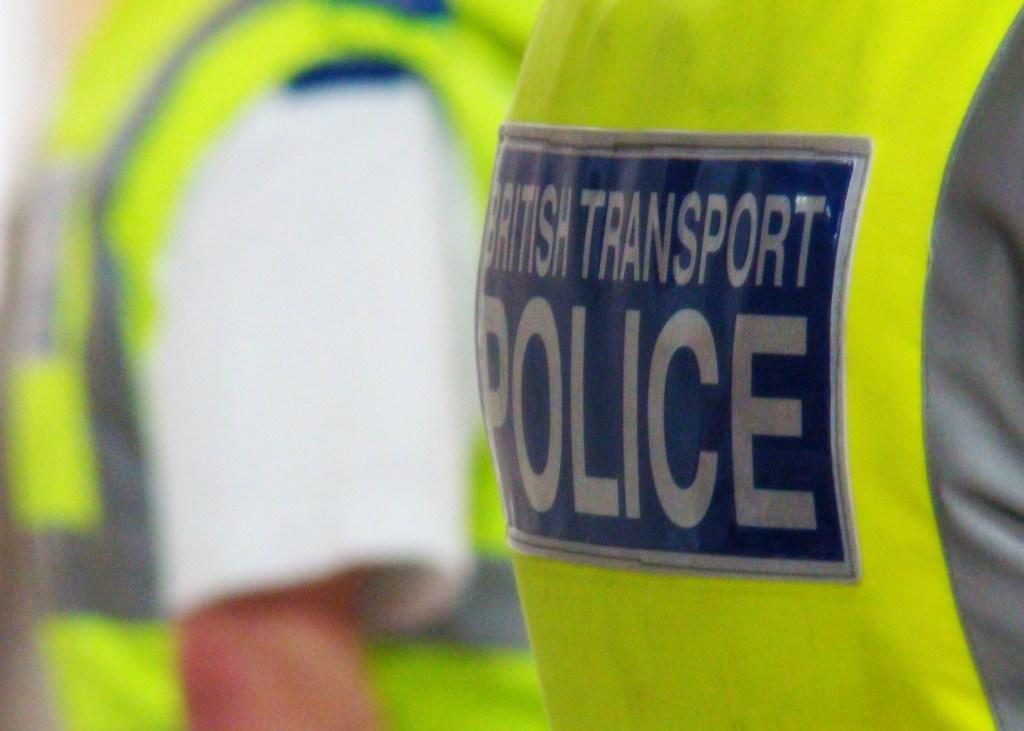<image>
Write a terse but informative summary of the picture. The hi visibility yellow vest worn by a British Transport police. 